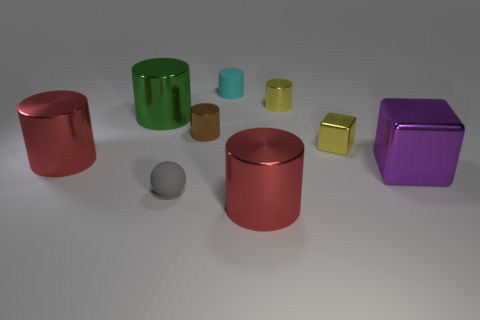There is a block behind the purple cube; what is its color?
Ensure brevity in your answer.  Yellow. Are there any big green cylinders behind the tiny cylinder that is in front of the big green object?
Keep it short and to the point. Yes. There is a big purple metal thing; does it have the same shape as the small metal object in front of the brown cylinder?
Give a very brief answer. Yes. How big is the cylinder that is both right of the cyan matte cylinder and in front of the big green metal cylinder?
Provide a short and direct response. Large. Is there a gray thing that has the same material as the small cyan cylinder?
Ensure brevity in your answer.  Yes. The large object behind the red cylinder left of the gray object is made of what material?
Provide a short and direct response. Metal. How many small metal objects have the same color as the tiny cube?
Give a very brief answer. 1. What size is the purple cube that is the same material as the tiny yellow cylinder?
Provide a short and direct response. Large. What is the shape of the tiny yellow thing that is in front of the yellow cylinder?
Make the answer very short. Cube. The green object that is the same shape as the cyan object is what size?
Keep it short and to the point. Large. 